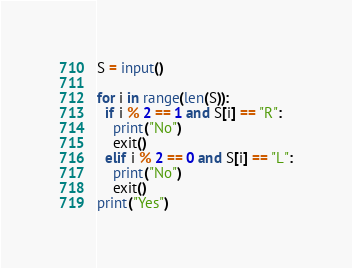Convert code to text. <code><loc_0><loc_0><loc_500><loc_500><_Python_>S = input()

for i in range(len(S)):
  if i % 2 == 1 and S[i] == "R":
    print("No")
    exit()
  elif i % 2 == 0 and S[i] == "L":
    print("No")
    exit()
print("Yes")</code> 